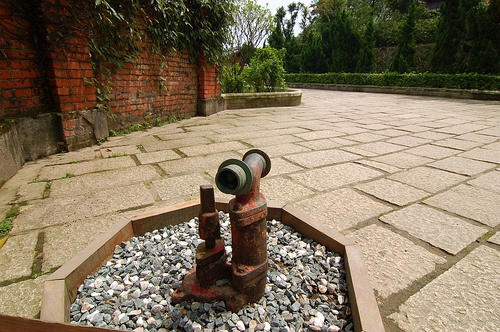Describe the objects in this image and their specific colors. I can see a fire hydrant in black, maroon, and gray tones in this image. 